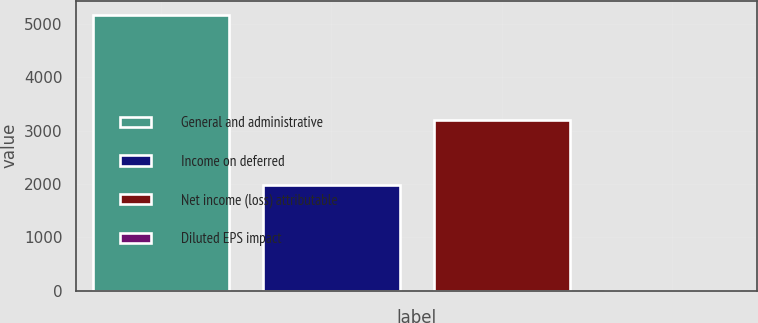<chart> <loc_0><loc_0><loc_500><loc_500><bar_chart><fcel>General and administrative<fcel>Income on deferred<fcel>Net income (loss) attributable<fcel>Diluted EPS impact<nl><fcel>5180<fcel>1982<fcel>3198<fcel>0.04<nl></chart> 